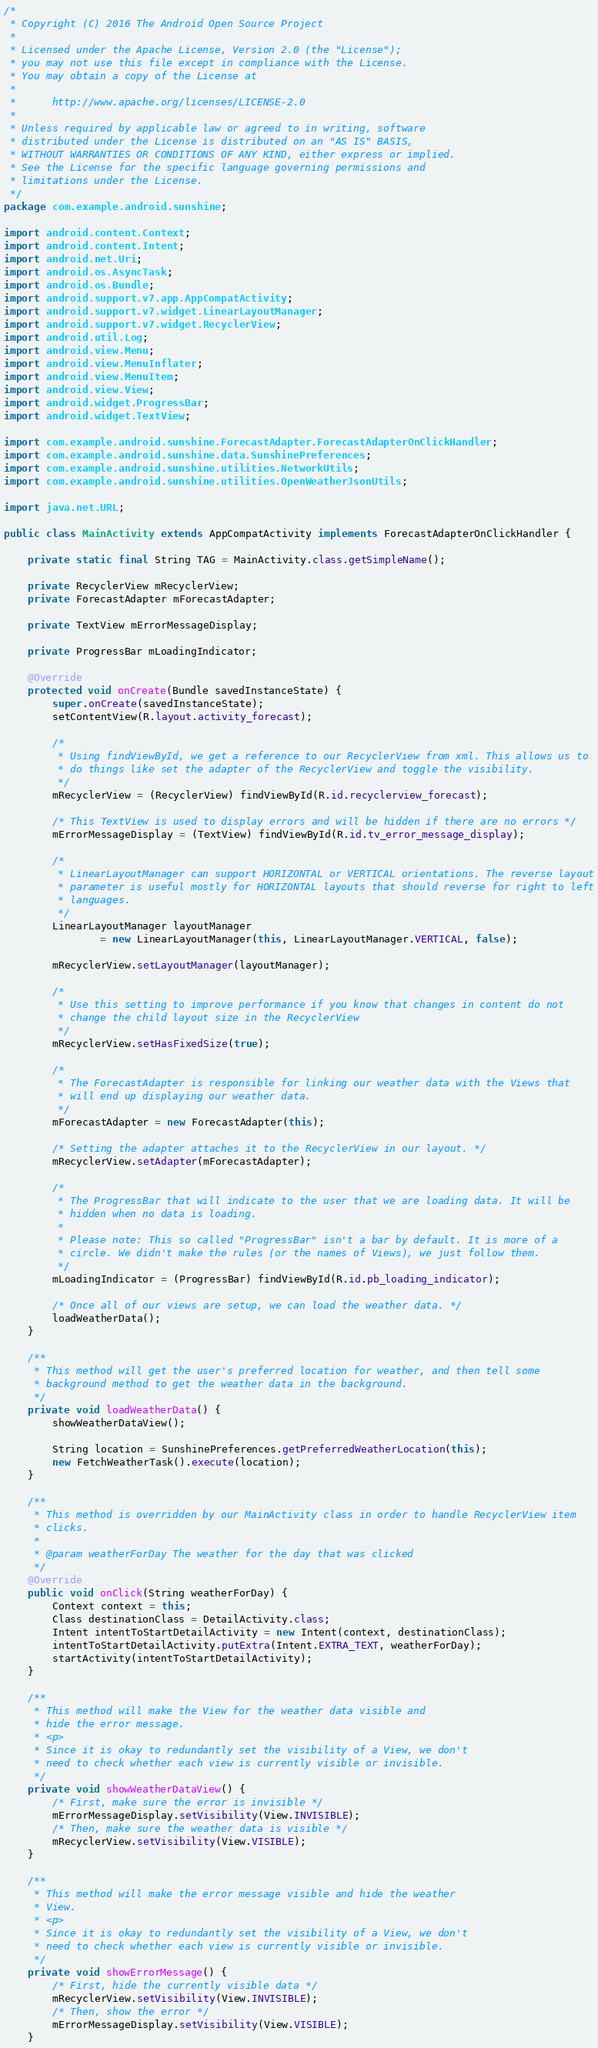Convert code to text. <code><loc_0><loc_0><loc_500><loc_500><_Java_>/*
 * Copyright (C) 2016 The Android Open Source Project
 *
 * Licensed under the Apache License, Version 2.0 (the "License");
 * you may not use this file except in compliance with the License.
 * You may obtain a copy of the License at
 *
 *      http://www.apache.org/licenses/LICENSE-2.0
 *
 * Unless required by applicable law or agreed to in writing, software
 * distributed under the License is distributed on an "AS IS" BASIS,
 * WITHOUT WARRANTIES OR CONDITIONS OF ANY KIND, either express or implied.
 * See the License for the specific language governing permissions and
 * limitations under the License.
 */
package com.example.android.sunshine;

import android.content.Context;
import android.content.Intent;
import android.net.Uri;
import android.os.AsyncTask;
import android.os.Bundle;
import android.support.v7.app.AppCompatActivity;
import android.support.v7.widget.LinearLayoutManager;
import android.support.v7.widget.RecyclerView;
import android.util.Log;
import android.view.Menu;
import android.view.MenuInflater;
import android.view.MenuItem;
import android.view.View;
import android.widget.ProgressBar;
import android.widget.TextView;

import com.example.android.sunshine.ForecastAdapter.ForecastAdapterOnClickHandler;
import com.example.android.sunshine.data.SunshinePreferences;
import com.example.android.sunshine.utilities.NetworkUtils;
import com.example.android.sunshine.utilities.OpenWeatherJsonUtils;

import java.net.URL;

public class MainActivity extends AppCompatActivity implements ForecastAdapterOnClickHandler {

    private static final String TAG = MainActivity.class.getSimpleName();

    private RecyclerView mRecyclerView;
    private ForecastAdapter mForecastAdapter;

    private TextView mErrorMessageDisplay;

    private ProgressBar mLoadingIndicator;

    @Override
    protected void onCreate(Bundle savedInstanceState) {
        super.onCreate(savedInstanceState);
        setContentView(R.layout.activity_forecast);

        /*
         * Using findViewById, we get a reference to our RecyclerView from xml. This allows us to
         * do things like set the adapter of the RecyclerView and toggle the visibility.
         */
        mRecyclerView = (RecyclerView) findViewById(R.id.recyclerview_forecast);

        /* This TextView is used to display errors and will be hidden if there are no errors */
        mErrorMessageDisplay = (TextView) findViewById(R.id.tv_error_message_display);

        /*
         * LinearLayoutManager can support HORIZONTAL or VERTICAL orientations. The reverse layout
         * parameter is useful mostly for HORIZONTAL layouts that should reverse for right to left
         * languages.
         */
        LinearLayoutManager layoutManager
                = new LinearLayoutManager(this, LinearLayoutManager.VERTICAL, false);

        mRecyclerView.setLayoutManager(layoutManager);

        /*
         * Use this setting to improve performance if you know that changes in content do not
         * change the child layout size in the RecyclerView
         */
        mRecyclerView.setHasFixedSize(true);

        /*
         * The ForecastAdapter is responsible for linking our weather data with the Views that
         * will end up displaying our weather data.
         */
        mForecastAdapter = new ForecastAdapter(this);

        /* Setting the adapter attaches it to the RecyclerView in our layout. */
        mRecyclerView.setAdapter(mForecastAdapter);

        /*
         * The ProgressBar that will indicate to the user that we are loading data. It will be
         * hidden when no data is loading.
         *
         * Please note: This so called "ProgressBar" isn't a bar by default. It is more of a
         * circle. We didn't make the rules (or the names of Views), we just follow them.
         */
        mLoadingIndicator = (ProgressBar) findViewById(R.id.pb_loading_indicator);

        /* Once all of our views are setup, we can load the weather data. */
        loadWeatherData();
    }

    /**
     * This method will get the user's preferred location for weather, and then tell some
     * background method to get the weather data in the background.
     */
    private void loadWeatherData() {
        showWeatherDataView();

        String location = SunshinePreferences.getPreferredWeatherLocation(this);
        new FetchWeatherTask().execute(location);
    }

    /**
     * This method is overridden by our MainActivity class in order to handle RecyclerView item
     * clicks.
     *
     * @param weatherForDay The weather for the day that was clicked
     */
    @Override
    public void onClick(String weatherForDay) {
        Context context = this;
        Class destinationClass = DetailActivity.class;
        Intent intentToStartDetailActivity = new Intent(context, destinationClass);
        intentToStartDetailActivity.putExtra(Intent.EXTRA_TEXT, weatherForDay);
        startActivity(intentToStartDetailActivity);
    }

    /**
     * This method will make the View for the weather data visible and
     * hide the error message.
     * <p>
     * Since it is okay to redundantly set the visibility of a View, we don't
     * need to check whether each view is currently visible or invisible.
     */
    private void showWeatherDataView() {
        /* First, make sure the error is invisible */
        mErrorMessageDisplay.setVisibility(View.INVISIBLE);
        /* Then, make sure the weather data is visible */
        mRecyclerView.setVisibility(View.VISIBLE);
    }

    /**
     * This method will make the error message visible and hide the weather
     * View.
     * <p>
     * Since it is okay to redundantly set the visibility of a View, we don't
     * need to check whether each view is currently visible or invisible.
     */
    private void showErrorMessage() {
        /* First, hide the currently visible data */
        mRecyclerView.setVisibility(View.INVISIBLE);
        /* Then, show the error */
        mErrorMessageDisplay.setVisibility(View.VISIBLE);
    }
</code> 